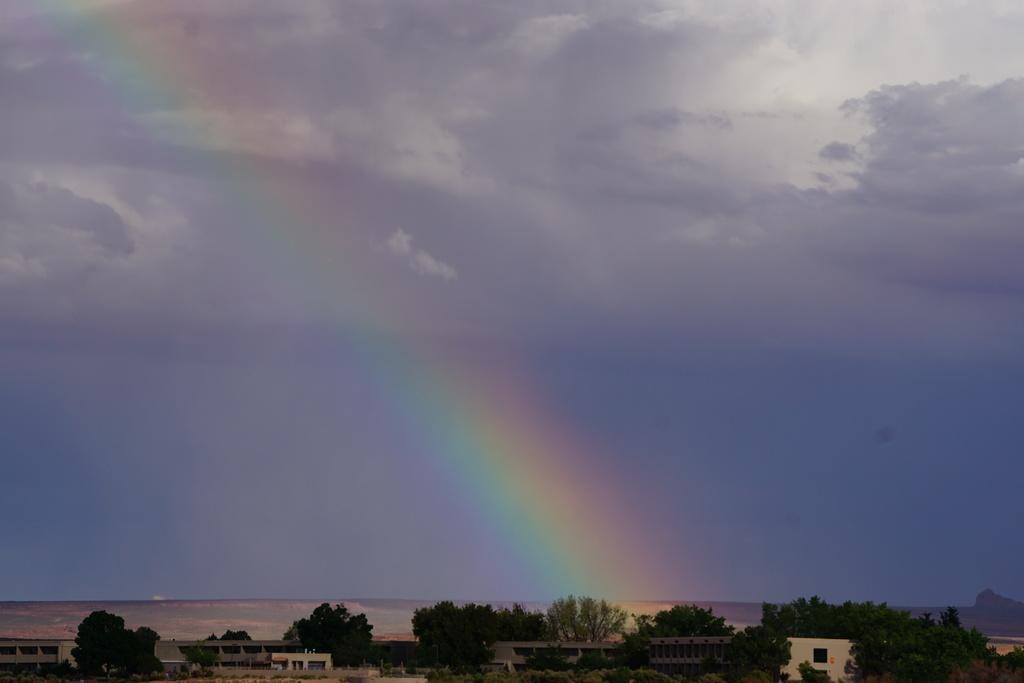How would you summarize this image in a sentence or two? In this image we can see some buildings, one mountain, some trees, bushes, plants and grass on the surface. At the top there is the cloudy sky with rainbow. 